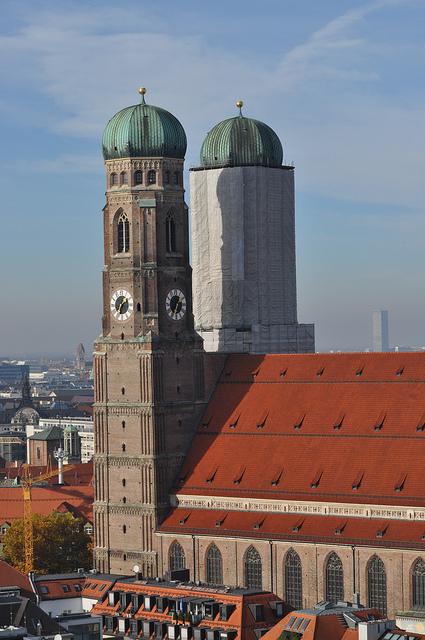What color is the roof of the building?
Be succinct. Red. What color is the dome of the building?
Give a very brief answer. Green. Are there clouds in the sky?
Quick response, please. Yes. 